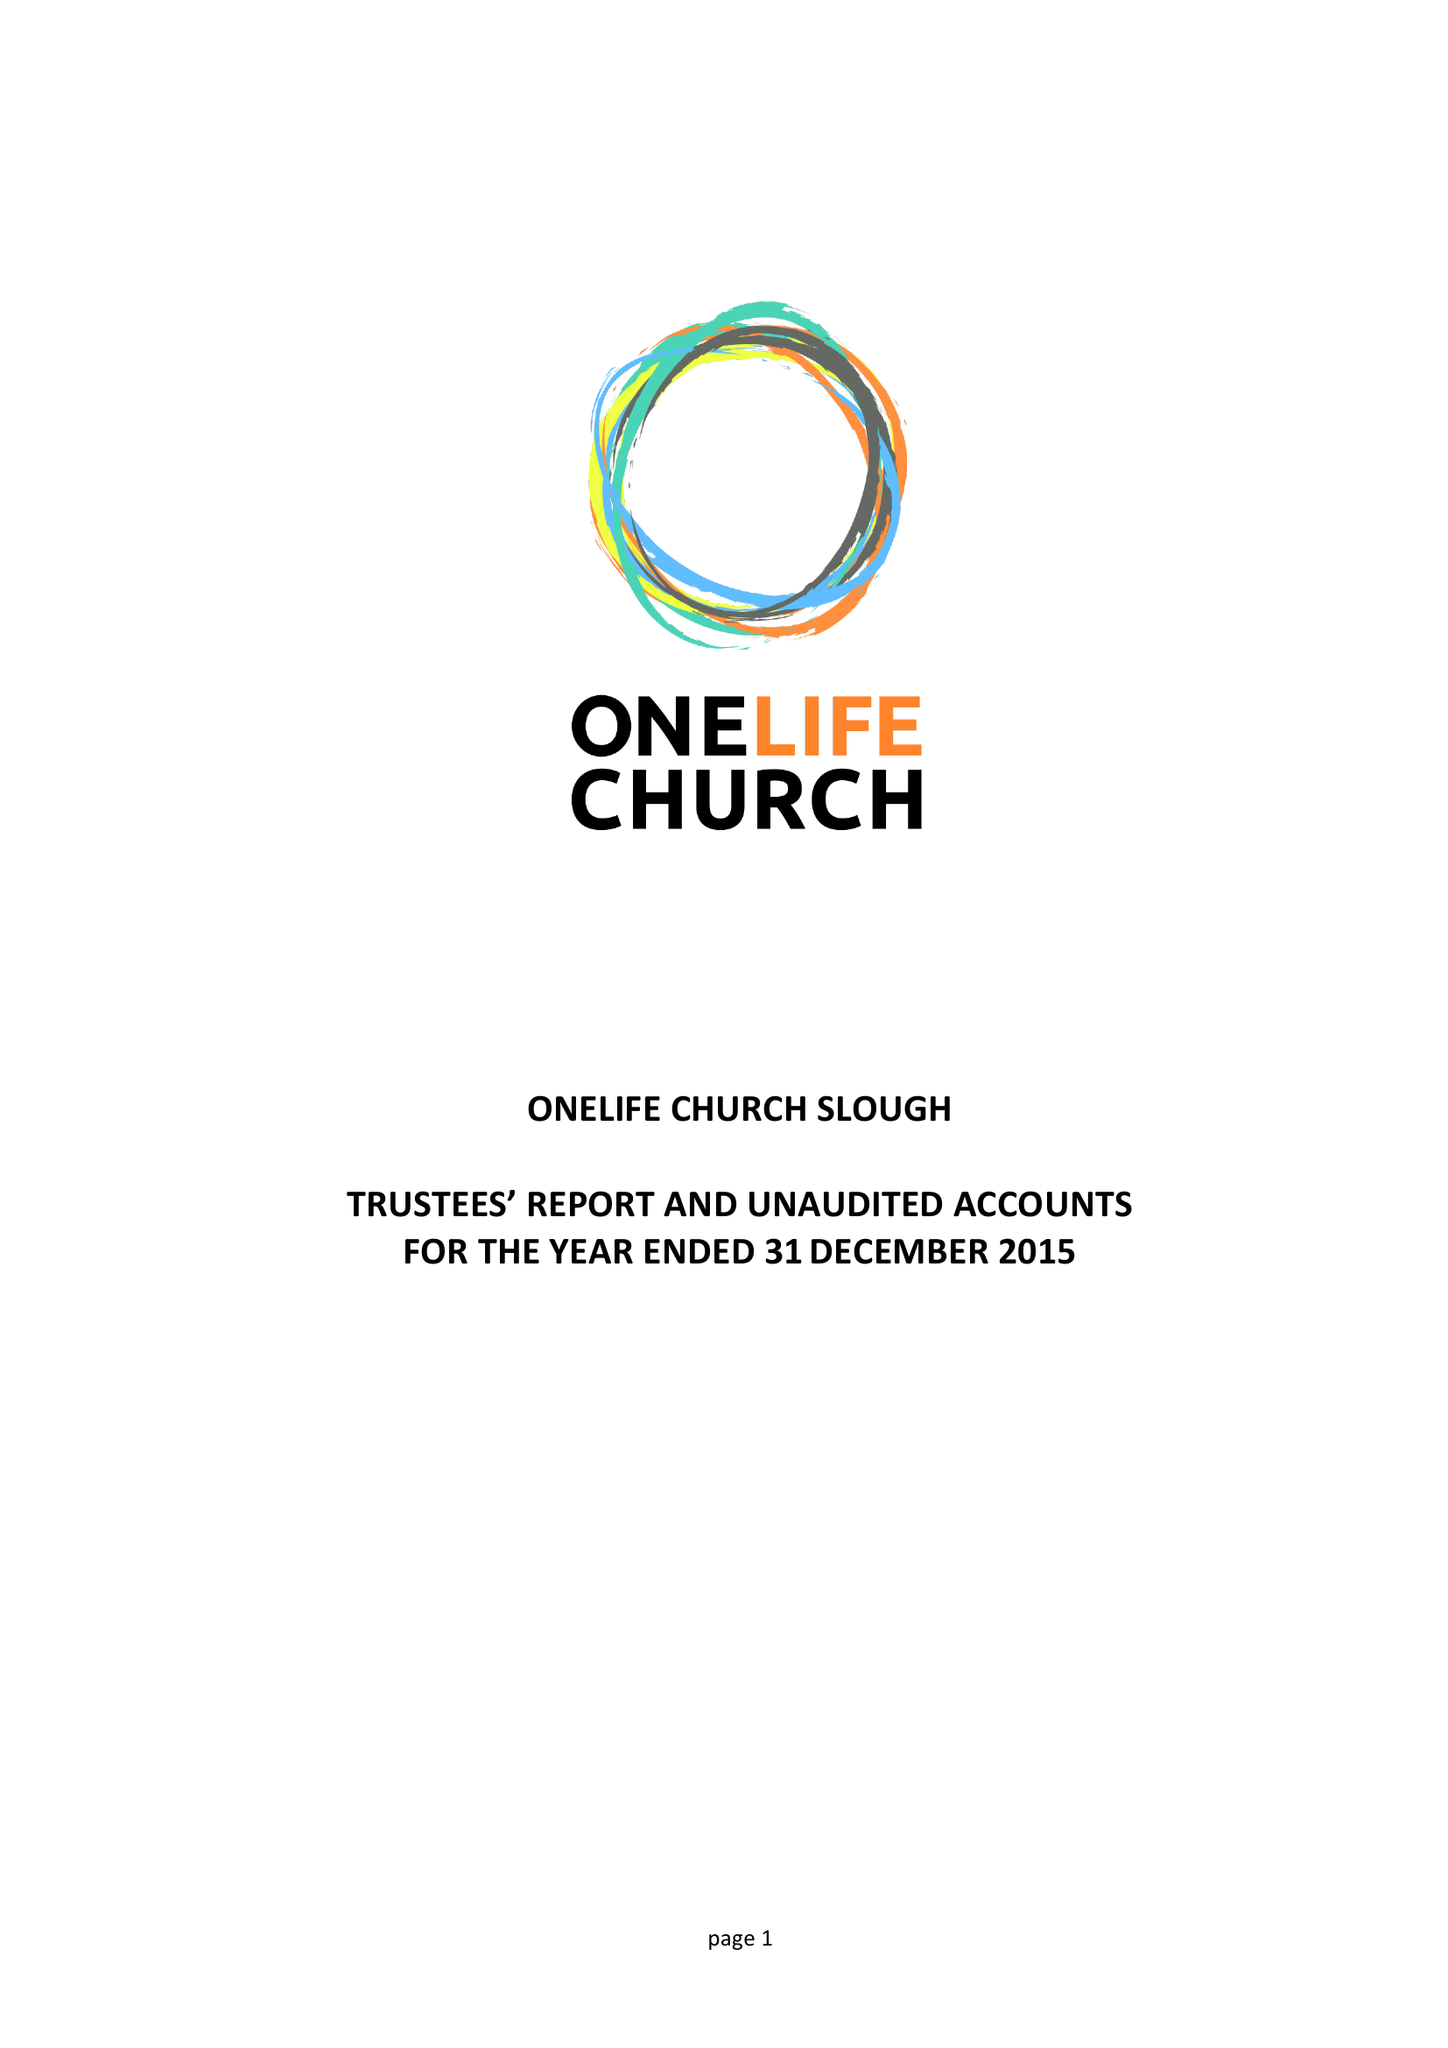What is the value for the address__street_line?
Answer the question using a single word or phrase. 306 SCAFELL ROAD 